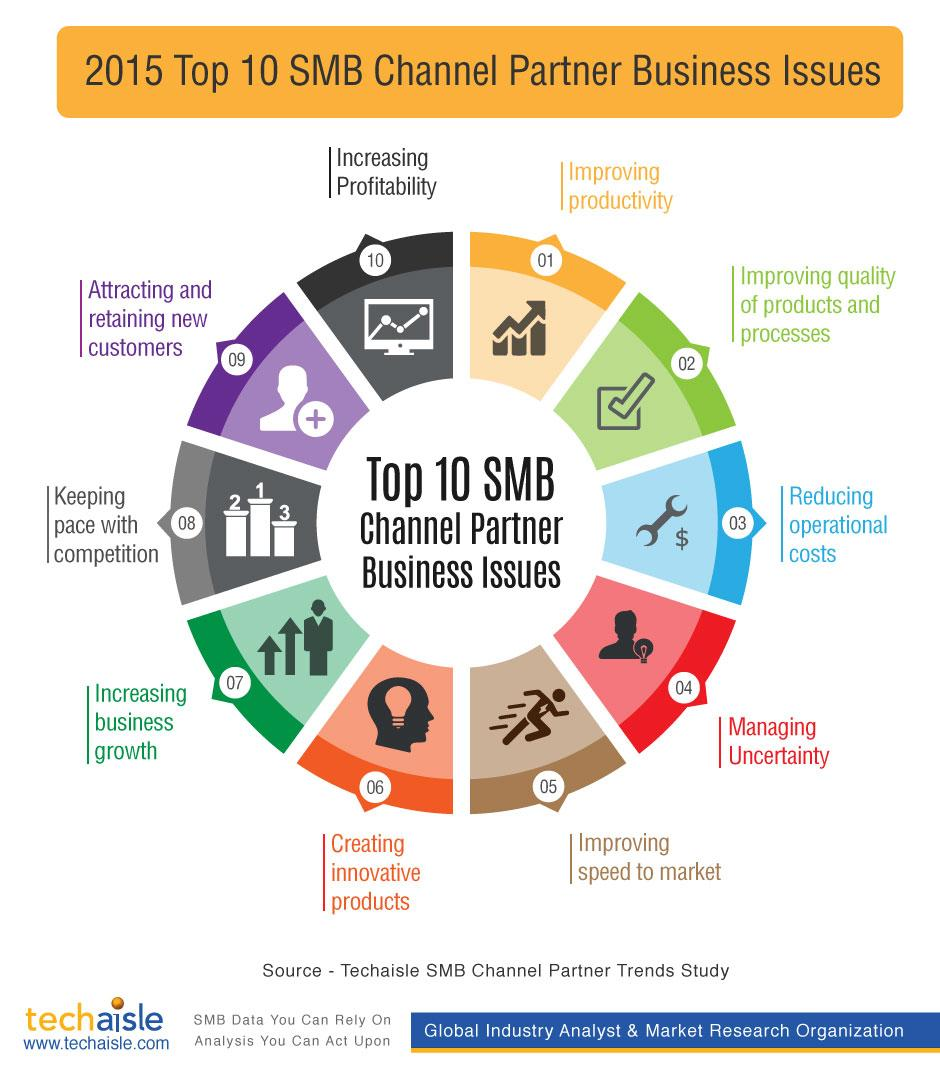Identify some key points in this picture. The fifth business issue mentioned in the infographic is improving speed to market. The color code for the issue "Increasing Profitability" is green, blue, orange, and black. The fourth business issue mentioned in the infographic is managing uncertainty. The second business issue mentioned in the infographic is improving the quality of products and processes. 